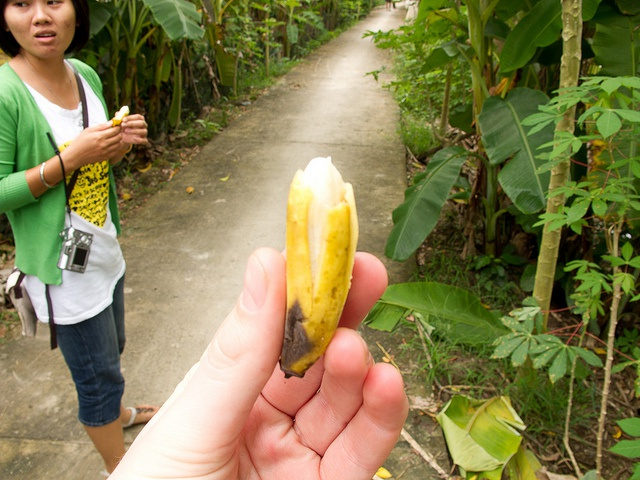Describe the objects in this image and their specific colors. I can see people in black, lightgray, green, and brown tones, people in black, white, and salmon tones, banana in black, gold, khaki, orange, and beige tones, handbag in black, lightgray, gray, and darkgray tones, and banana in black, ivory, orange, khaki, and gold tones in this image. 